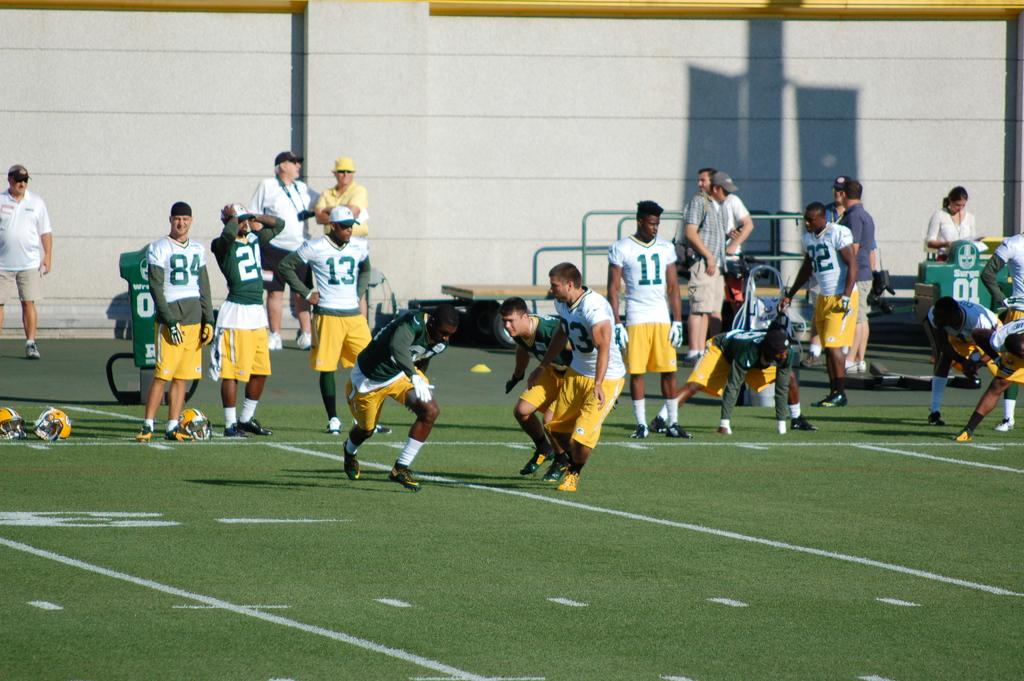<image>
Write a terse but informative summary of the picture. Players in unifoms numbered 11, 84 and 13 watch a game from the sidelines. 